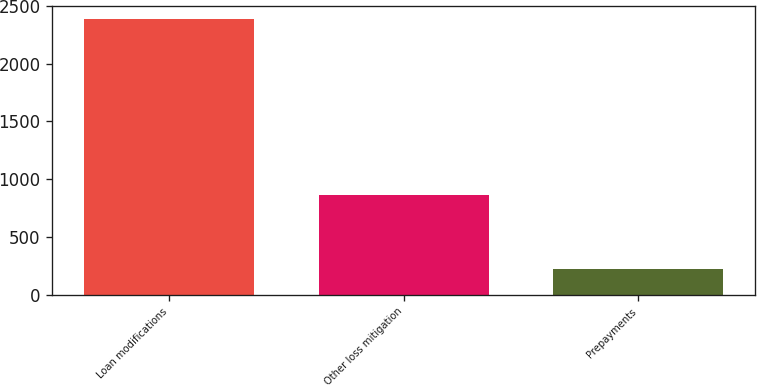Convert chart to OTSL. <chart><loc_0><loc_0><loc_500><loc_500><bar_chart><fcel>Loan modifications<fcel>Other loss mitigation<fcel>Prepayments<nl><fcel>2384<fcel>865<fcel>219<nl></chart> 